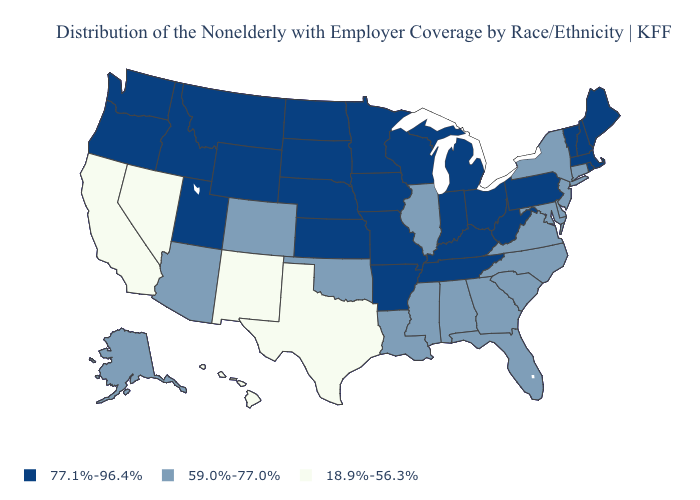Does Utah have a lower value than Kentucky?
Short answer required. No. Name the states that have a value in the range 59.0%-77.0%?
Quick response, please. Alabama, Alaska, Arizona, Colorado, Connecticut, Delaware, Florida, Georgia, Illinois, Louisiana, Maryland, Mississippi, New Jersey, New York, North Carolina, Oklahoma, South Carolina, Virginia. Does California have the lowest value in the USA?
Write a very short answer. Yes. Is the legend a continuous bar?
Short answer required. No. What is the value of North Dakota?
Short answer required. 77.1%-96.4%. What is the value of Idaho?
Quick response, please. 77.1%-96.4%. Name the states that have a value in the range 18.9%-56.3%?
Answer briefly. California, Hawaii, Nevada, New Mexico, Texas. Name the states that have a value in the range 77.1%-96.4%?
Short answer required. Arkansas, Idaho, Indiana, Iowa, Kansas, Kentucky, Maine, Massachusetts, Michigan, Minnesota, Missouri, Montana, Nebraska, New Hampshire, North Dakota, Ohio, Oregon, Pennsylvania, Rhode Island, South Dakota, Tennessee, Utah, Vermont, Washington, West Virginia, Wisconsin, Wyoming. What is the highest value in the USA?
Keep it brief. 77.1%-96.4%. Among the states that border Washington , which have the lowest value?
Keep it brief. Idaho, Oregon. What is the value of Alabama?
Give a very brief answer. 59.0%-77.0%. Among the states that border Oklahoma , does New Mexico have the lowest value?
Give a very brief answer. Yes. Which states have the highest value in the USA?
Answer briefly. Arkansas, Idaho, Indiana, Iowa, Kansas, Kentucky, Maine, Massachusetts, Michigan, Minnesota, Missouri, Montana, Nebraska, New Hampshire, North Dakota, Ohio, Oregon, Pennsylvania, Rhode Island, South Dakota, Tennessee, Utah, Vermont, Washington, West Virginia, Wisconsin, Wyoming. What is the value of Missouri?
Be succinct. 77.1%-96.4%. Name the states that have a value in the range 18.9%-56.3%?
Short answer required. California, Hawaii, Nevada, New Mexico, Texas. 